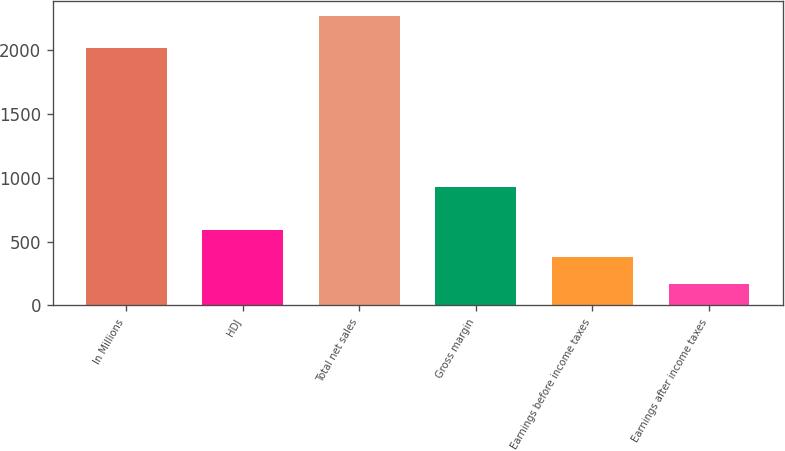Convert chart to OTSL. <chart><loc_0><loc_0><loc_500><loc_500><bar_chart><fcel>In Millions<fcel>HDJ<fcel>Total net sales<fcel>Gross margin<fcel>Earnings before income taxes<fcel>Earnings after income taxes<nl><fcel>2015<fcel>589.5<fcel>2264.7<fcel>925.4<fcel>380.1<fcel>170.7<nl></chart> 